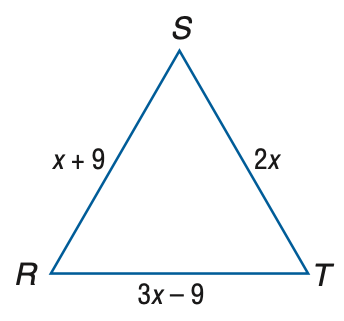Answer the mathemtical geometry problem and directly provide the correct option letter.
Question: Find the measure of R T of equilateral triangle R S T if R S = x + 9, S T = 2 x, and R T = 3 x - 9.
Choices: A: 9 B: 12 C: 15 D: 18 D 